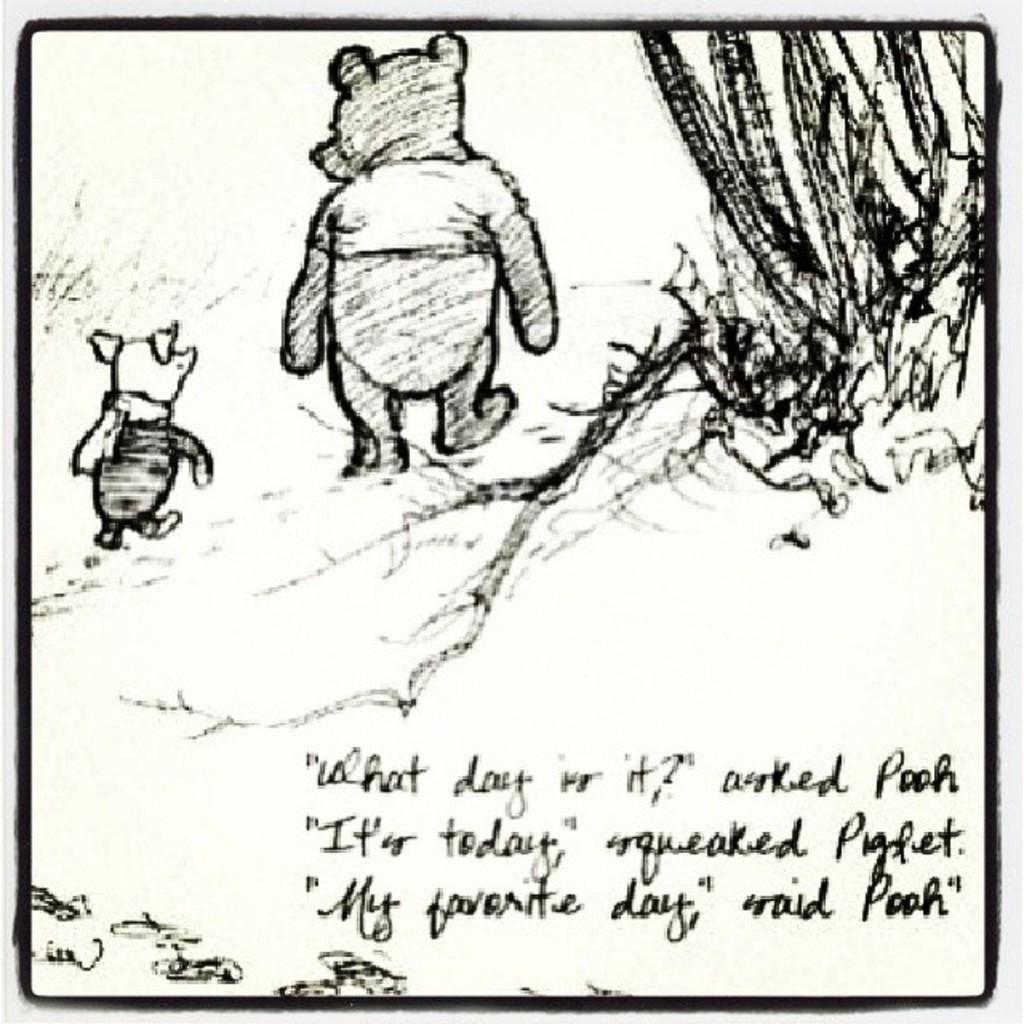Please provide a concise description of this image. This image is a drawing. In the center of the image there are two animals. To the right side of the image there is plant. There is some text written at the bottom of the image. 